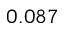Convert formula to latex. <formula><loc_0><loc_0><loc_500><loc_500>0 . 0 8 7</formula> 